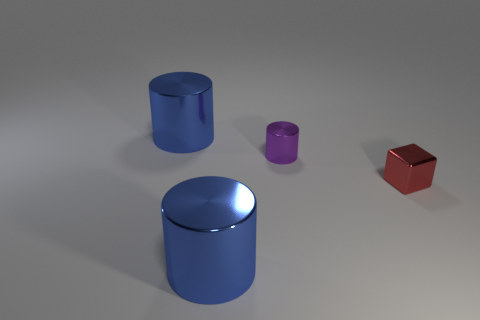How many other things are the same shape as the tiny purple metal object?
Offer a terse response. 2. What size is the purple object behind the large blue cylinder that is in front of the small red cube?
Keep it short and to the point. Small. Are there any large red metallic cylinders?
Provide a succinct answer. No. There is a metallic thing that is on the right side of the purple thing; how many shiny cylinders are in front of it?
Offer a terse response. 1. There is a blue metal object that is behind the small red thing; what shape is it?
Provide a short and direct response. Cylinder. What color is the small block?
Your answer should be compact. Red. There is a big object on the right side of the large shiny thing that is behind the purple shiny cylinder; what is its color?
Offer a terse response. Blue. There is a large shiny cylinder that is in front of the small thing that is on the right side of the purple cylinder; what number of metallic things are behind it?
Offer a terse response. 3. Are there any red blocks to the right of the tiny red object?
Provide a short and direct response. No. Is there anything else that is the same color as the small cylinder?
Offer a terse response. No. 